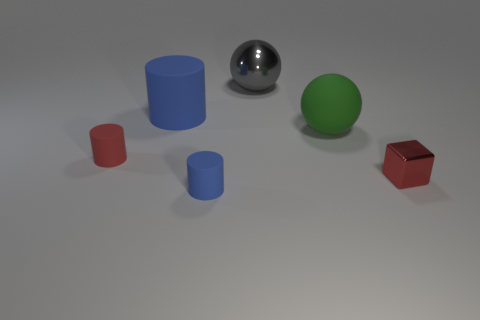Subtract all red cubes. How many blue cylinders are left? 2 Subtract all blue cylinders. How many cylinders are left? 1 Add 2 big gray blocks. How many objects exist? 8 Subtract all balls. How many objects are left? 4 Subtract 0 green blocks. How many objects are left? 6 Subtract all gray cubes. Subtract all blocks. How many objects are left? 5 Add 1 small shiny cubes. How many small shiny cubes are left? 2 Add 5 blue matte objects. How many blue matte objects exist? 7 